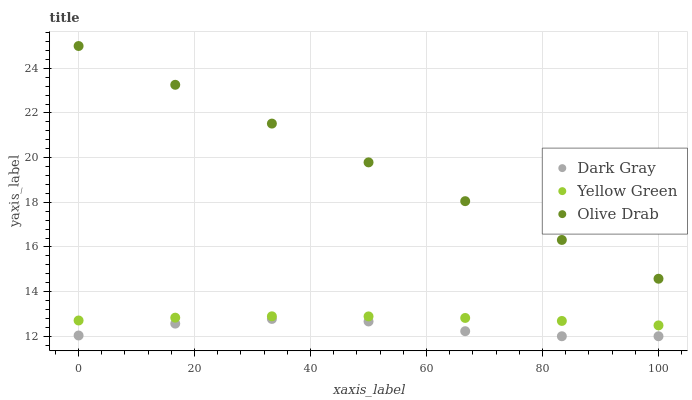Does Dark Gray have the minimum area under the curve?
Answer yes or no. Yes. Does Olive Drab have the maximum area under the curve?
Answer yes or no. Yes. Does Yellow Green have the minimum area under the curve?
Answer yes or no. No. Does Yellow Green have the maximum area under the curve?
Answer yes or no. No. Is Olive Drab the smoothest?
Answer yes or no. Yes. Is Dark Gray the roughest?
Answer yes or no. Yes. Is Yellow Green the smoothest?
Answer yes or no. No. Is Yellow Green the roughest?
Answer yes or no. No. Does Dark Gray have the lowest value?
Answer yes or no. Yes. Does Yellow Green have the lowest value?
Answer yes or no. No. Does Olive Drab have the highest value?
Answer yes or no. Yes. Does Yellow Green have the highest value?
Answer yes or no. No. Is Yellow Green less than Olive Drab?
Answer yes or no. Yes. Is Olive Drab greater than Yellow Green?
Answer yes or no. Yes. Does Yellow Green intersect Olive Drab?
Answer yes or no. No. 